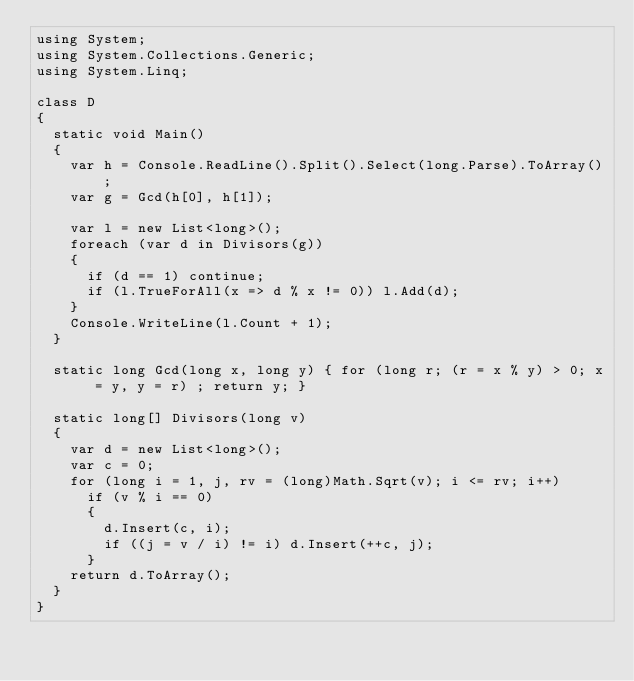Convert code to text. <code><loc_0><loc_0><loc_500><loc_500><_C#_>using System;
using System.Collections.Generic;
using System.Linq;

class D
{
	static void Main()
	{
		var h = Console.ReadLine().Split().Select(long.Parse).ToArray();
		var g = Gcd(h[0], h[1]);

		var l = new List<long>();
		foreach (var d in Divisors(g))
		{
			if (d == 1) continue;
			if (l.TrueForAll(x => d % x != 0)) l.Add(d);
		}
		Console.WriteLine(l.Count + 1);
	}

	static long Gcd(long x, long y) { for (long r; (r = x % y) > 0; x = y, y = r) ; return y; }

	static long[] Divisors(long v)
	{
		var d = new List<long>();
		var c = 0;
		for (long i = 1, j, rv = (long)Math.Sqrt(v); i <= rv; i++)
			if (v % i == 0)
			{
				d.Insert(c, i);
				if ((j = v / i) != i) d.Insert(++c, j);
			}
		return d.ToArray();
	}
}
</code> 